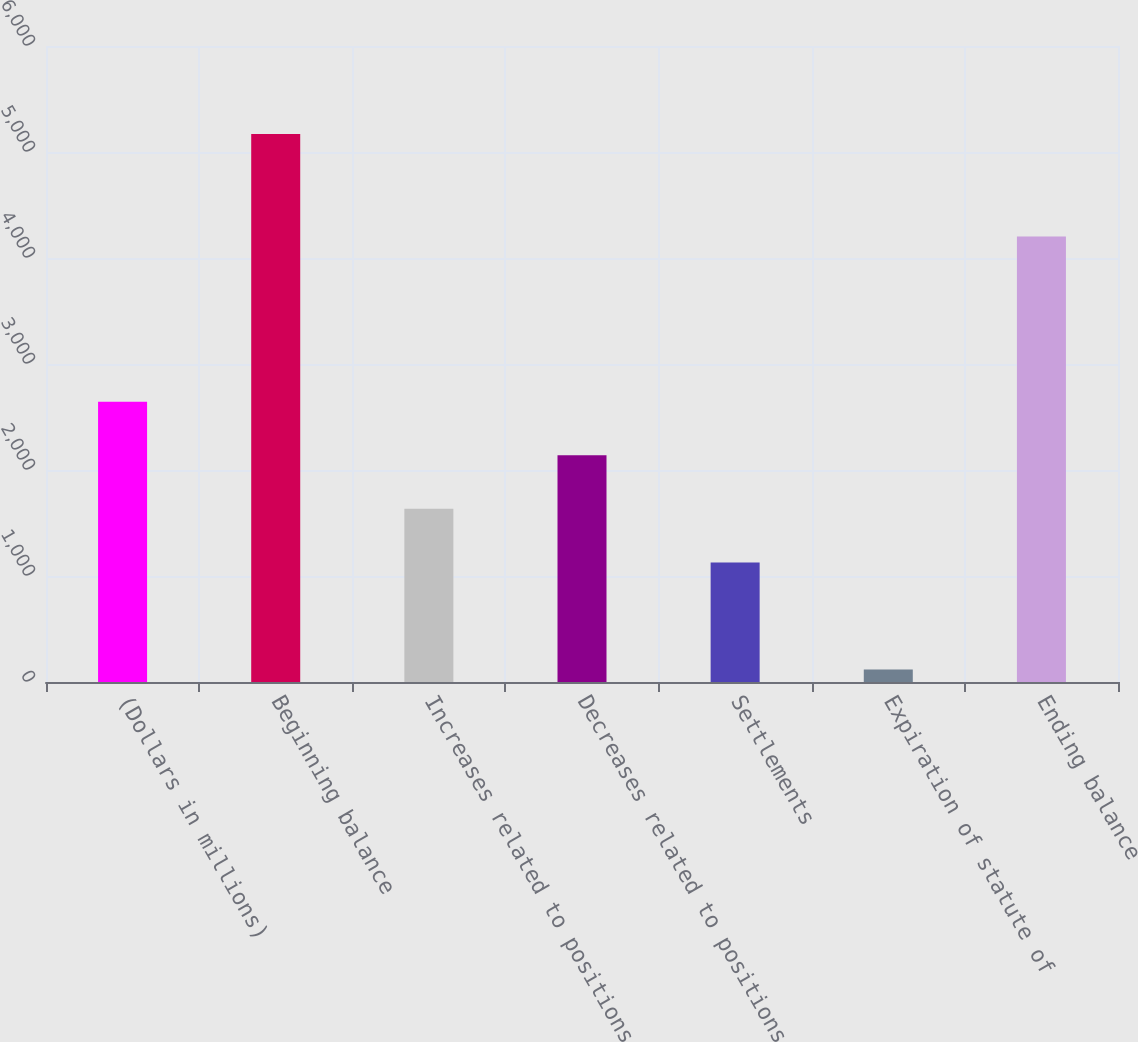Convert chart. <chart><loc_0><loc_0><loc_500><loc_500><bar_chart><fcel>(Dollars in millions)<fcel>Beginning balance<fcel>Increases related to positions<fcel>Decreases related to positions<fcel>Settlements<fcel>Expiration of statute of<fcel>Ending balance<nl><fcel>2643.5<fcel>5169<fcel>1633.3<fcel>2138.4<fcel>1128.2<fcel>118<fcel>4203<nl></chart> 